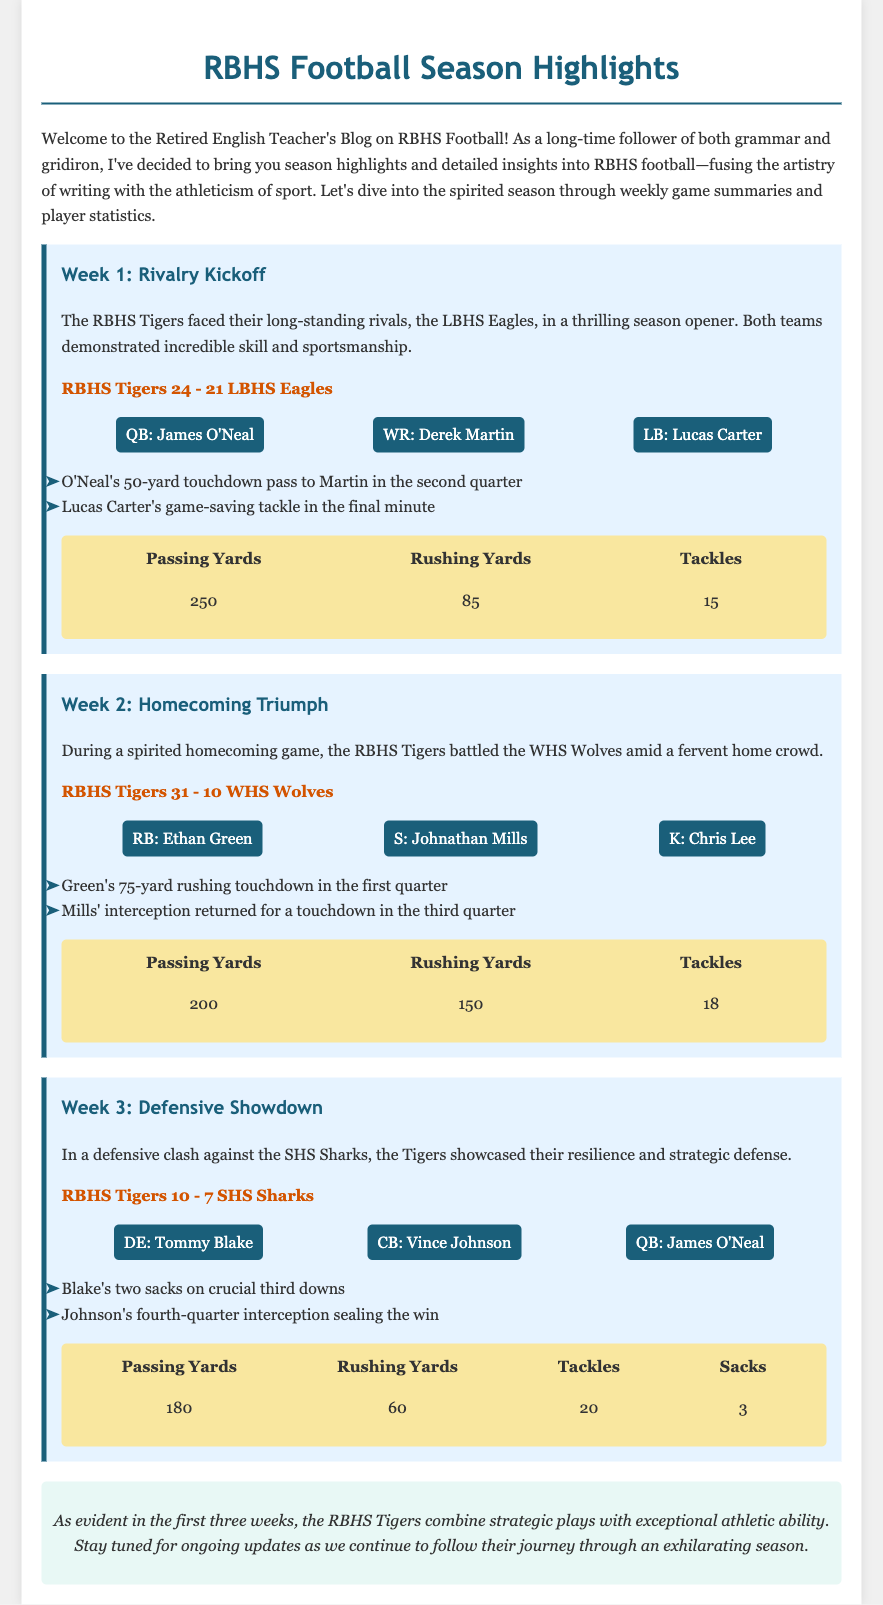What was the score in Week 1? The score in Week 1 indicates the final results of the game between the RBHS Tigers and the LBHS Eagles.
Answer: RBHS Tigers 24 - 21 LBHS Eagles Who was the key player for RBHS in Week 2? The key players are listed for each week, showing who had significant impact or contributions.
Answer: RB: Ethan Green How many rushing yards did RBHS have in Week 3? The rushing yards are specified in the stats section for each week's game summary.
Answer: 60 What significant play did Lucas Carter make in Week 1? The document lists important plays made by players during each game, showcasing their contributions.
Answer: game-saving tackle How many tackles did the Tigers have in Week 2? The number of tackles is part of the detailed statistics provided for each game summary.
Answer: 18 What type of game was played in Week 3? The description provides context about the nature of the game and the performance of the teams, indicating a focus on defense.
Answer: Defensive Showdown Who intercepted a pass for a touchdown in Week 2? The document highlights key player actions, naming those who made notable plays during the games.
Answer: Johnathan Mills What was the key moment for James O'Neal in Week 1? Important plays are listed in each game summary, detailing key actions by standout players.
Answer: 50-yard touchdown pass to Martin 